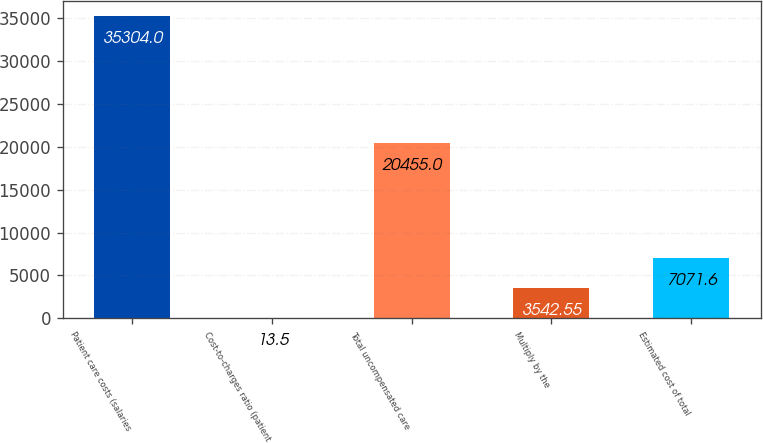<chart> <loc_0><loc_0><loc_500><loc_500><bar_chart><fcel>Patient care costs (salaries<fcel>Cost-to-charges ratio (patient<fcel>Total uncompensated care<fcel>Multiply by the<fcel>Estimated cost of total<nl><fcel>35304<fcel>13.5<fcel>20455<fcel>3542.55<fcel>7071.6<nl></chart> 